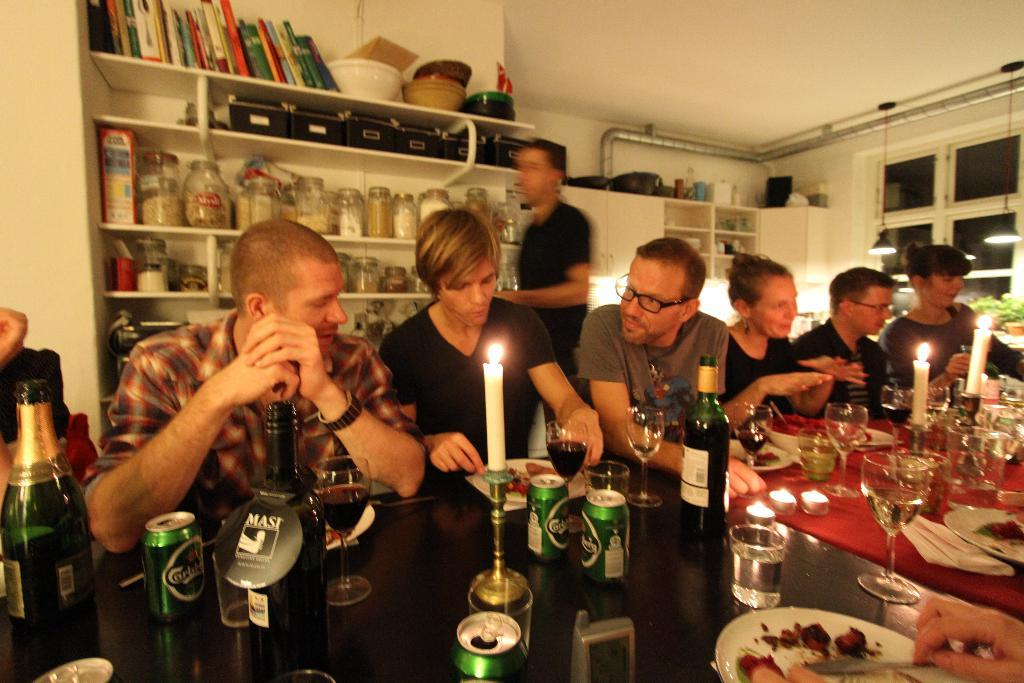What are the people in the image doing? The people in the image are sitting. What objects can be seen on the table in the image? There are glasses, cans, bottles, and candles on the table. What type of chain is hanging from the door in the image? There is no door or chain present in the image. How does the throat of the person sitting in the image look? The image does not show the throats of the people sitting, so it cannot be determined from the image. 